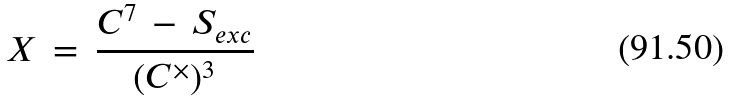<formula> <loc_0><loc_0><loc_500><loc_500>X \, = \, \frac { { C } ^ { 7 } \, - \, S _ { e x c } } { ( { C } ^ { \times } ) ^ { 3 } }</formula> 